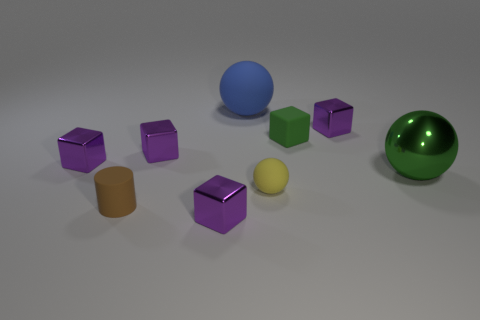How many other objects are there of the same shape as the small yellow rubber thing?
Your answer should be compact. 2. The green object behind the small purple object that is on the left side of the tiny brown matte object is made of what material?
Your answer should be compact. Rubber. There is a small green rubber block; are there any big blue balls in front of it?
Your answer should be compact. No. There is a brown rubber cylinder; is it the same size as the rubber thing behind the small green object?
Offer a terse response. No. There is a yellow object that is the same shape as the large blue thing; what size is it?
Provide a succinct answer. Small. Is there anything else that has the same material as the big blue thing?
Keep it short and to the point. Yes. There is a metal block that is to the left of the tiny brown matte cylinder; is its size the same as the matte thing to the right of the small rubber ball?
Offer a terse response. Yes. What number of large things are blue spheres or cylinders?
Keep it short and to the point. 1. How many purple blocks are behind the big metal thing and on the left side of the blue thing?
Offer a terse response. 2. Do the small green thing and the purple thing that is on the right side of the blue ball have the same material?
Ensure brevity in your answer.  No. 